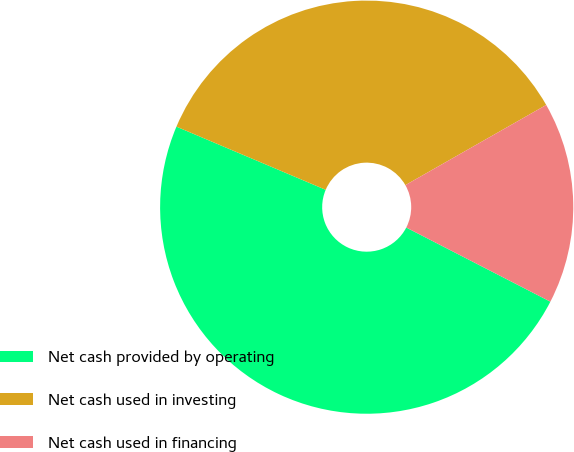<chart> <loc_0><loc_0><loc_500><loc_500><pie_chart><fcel>Net cash provided by operating<fcel>Net cash used in investing<fcel>Net cash used in financing<nl><fcel>48.81%<fcel>35.39%<fcel>15.8%<nl></chart> 